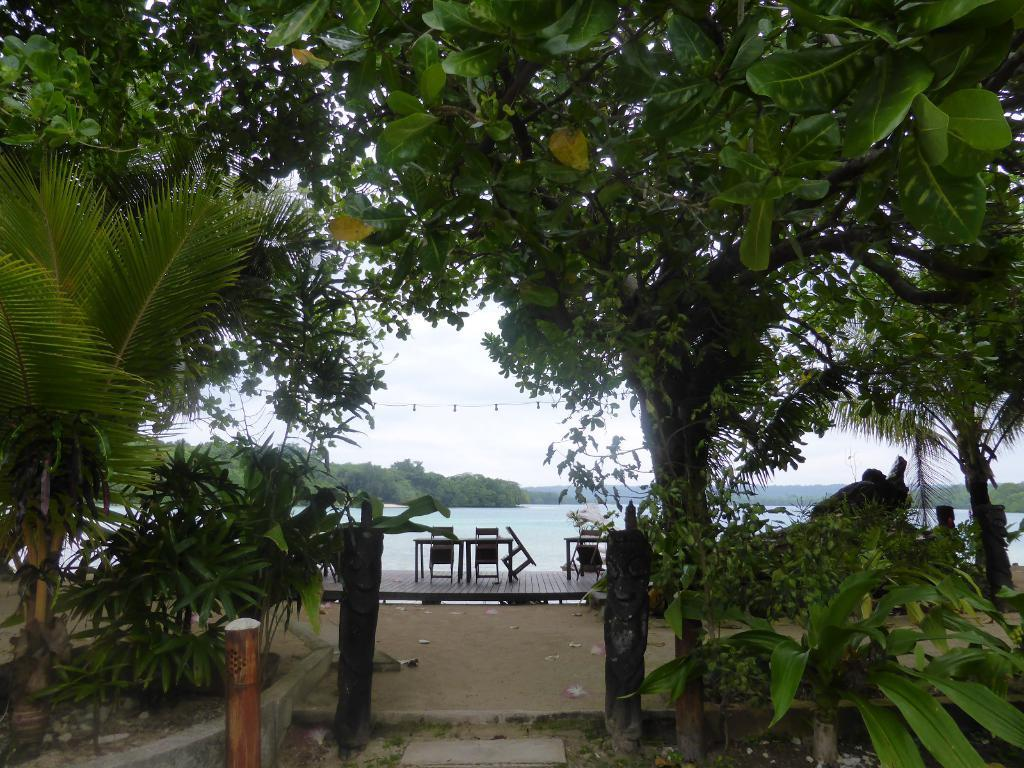What type of vegetation is present in the image? There are trees and plants in the image. What type of furniture can be seen in the distance? There are chairs in the distance. What other type of object can be seen in the distance? There is a table in the distance. What natural element is visible in the distance? There is water visible in the distance. How many balloons are floating above the table in the image? There are no balloons present in the image. How does the water move around in the image? The water does not move around in the image; it is stationary. 